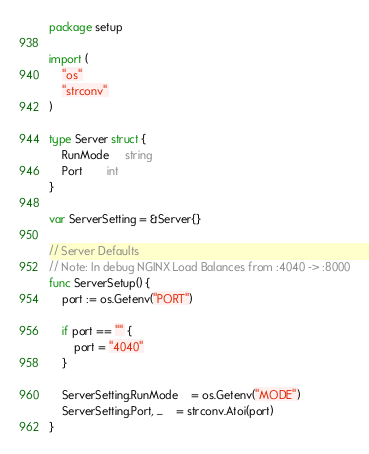<code> <loc_0><loc_0><loc_500><loc_500><_Go_>package setup

import (
    "os"
    "strconv"
)

type Server struct {
    RunMode     string
    Port        int
}

var ServerSetting = &Server{}

// Server Defaults
// Note: In debug NGINX Load Balances from :4040 -> :8000
func ServerSetup() {
    port := os.Getenv("PORT")

    if port == "" {
        port = "4040"
    }

    ServerSetting.RunMode    = os.Getenv("MODE")
    ServerSetting.Port, _    = strconv.Atoi(port)
}
</code> 